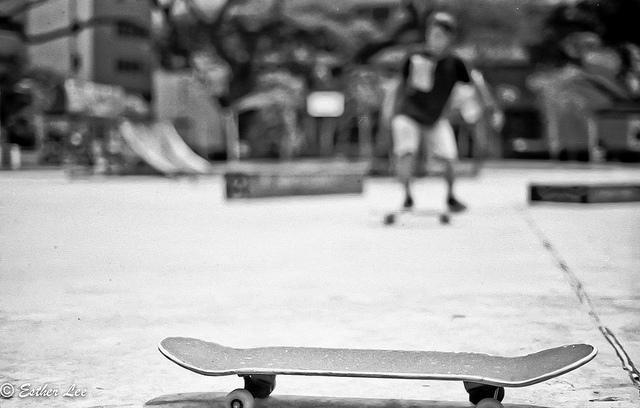How many black cars are driving to the left of the bus?
Give a very brief answer. 0. 